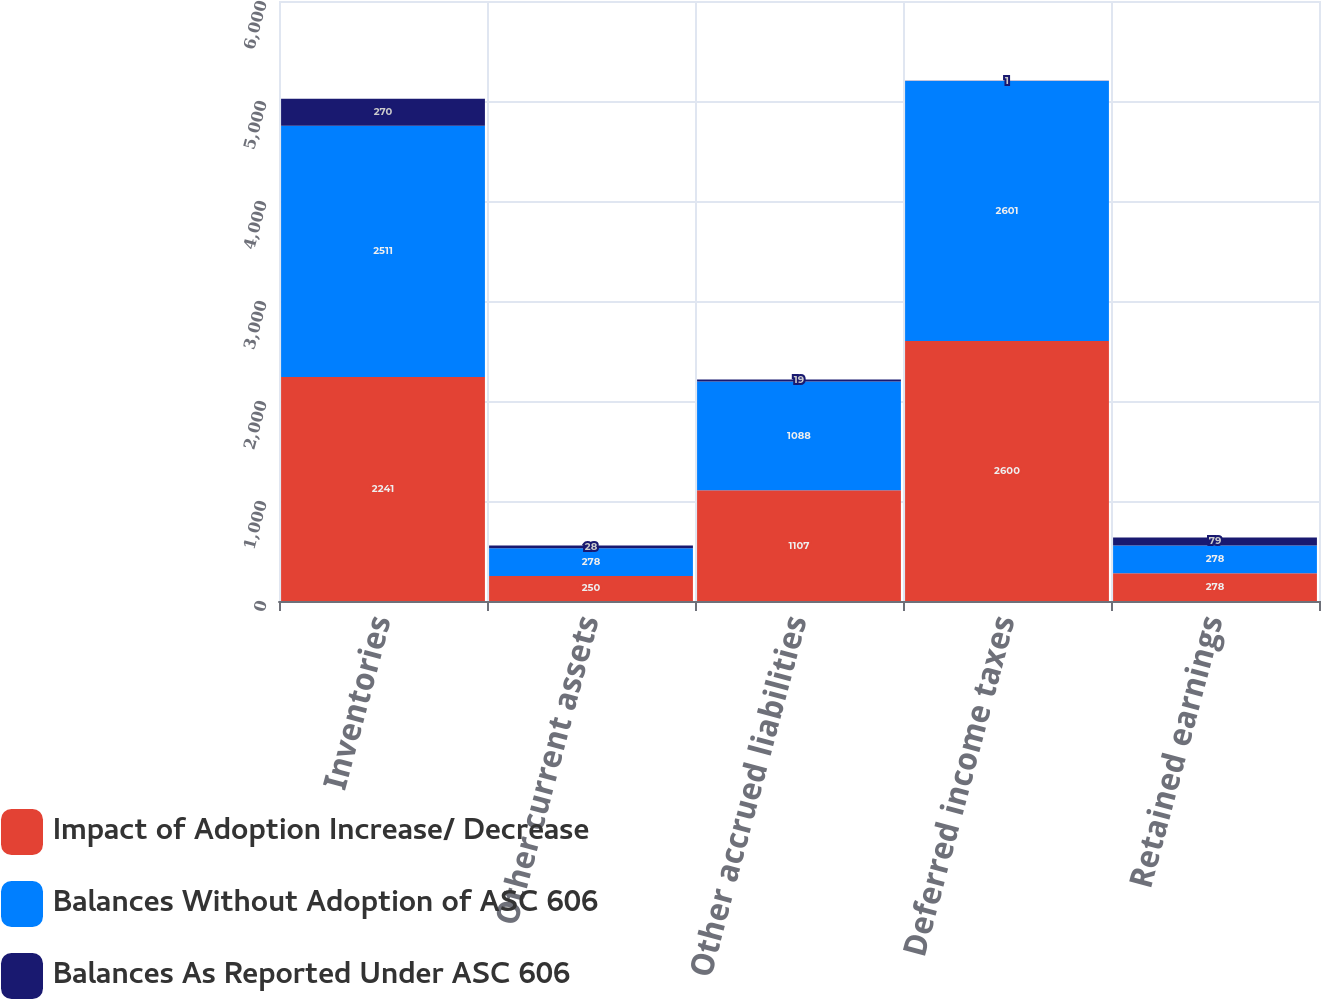Convert chart. <chart><loc_0><loc_0><loc_500><loc_500><stacked_bar_chart><ecel><fcel>Inventories<fcel>Other current assets<fcel>Other accrued liabilities<fcel>Deferred income taxes<fcel>Retained earnings<nl><fcel>Impact of Adoption Increase/ Decrease<fcel>2241<fcel>250<fcel>1107<fcel>2600<fcel>278<nl><fcel>Balances Without Adoption of ASC 606<fcel>2511<fcel>278<fcel>1088<fcel>2601<fcel>278<nl><fcel>Balances As Reported Under ASC 606<fcel>270<fcel>28<fcel>19<fcel>1<fcel>79<nl></chart> 